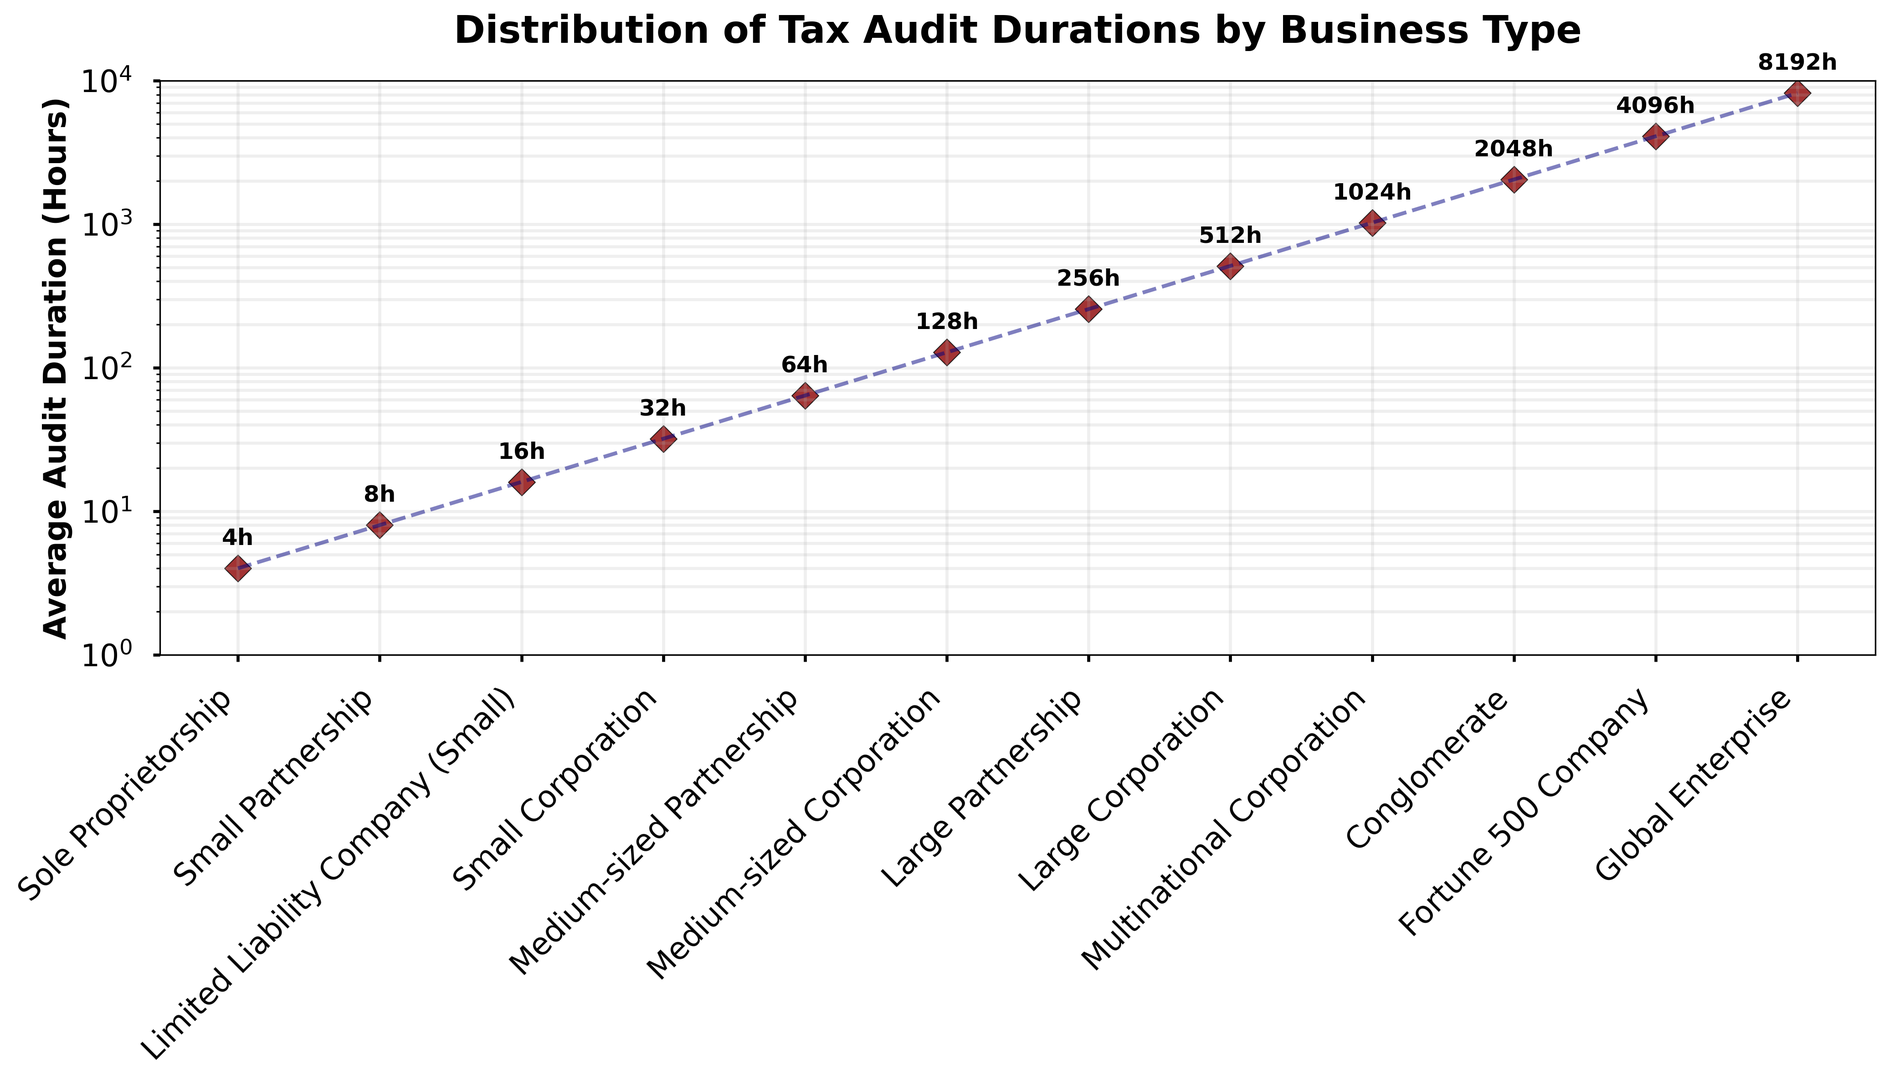What's the business type with the shortest average audit duration? By looking at the leftmost point on the x-axis (representing business types) and the lowest position on the y-axis (representing audit duration in hours), we see that "Sole Proprietorship" is located there. Its average audit duration is 4 hours.
Answer: Sole Proprietorship Which business type has the longest average audit duration? By examining the rightmost point on the x-axis and the highest position on the y-axis, we identify "Global Enterprise" as having the longest duration, which is 8192 hours.
Answer: Global Enterprise What is the average audit duration for "Large Corporation" and "Multinational Corporation"? Find the y-values for both "Large Corporation" and "Multinational Corporation" from the plot. They are 512 hours and 1024 hours, respectively. The average is calculated as (512 + 1024) / 2 = 768 hours.
Answer: 768 How much longer is the audit duration for a "Conglomerate" compared to a "Medium-sized Corporation"? The audit duration for a "Conglomerate" is 2048 hours and for a "Medium-sized Corporation" is 128 hours. The difference is 2048 - 128 = 1920 hours.
Answer: 1920 Rank the following business types by audit duration: "Small Corporation," "Medium-sized Partnership," and "Limited Liability Company (Small)". Locate each business on the x-axis and note their y-values. "Limited Liability Company (Small)" has 16 hours, "Small Corporation" has 32 hours, and "Medium-sized Partnership" has 64 hours. Ranking from shortest to longest gives: "Limited Liability Company (Small)", "Small Corporation", "Medium-sized Partnership".
Answer: Limited Liability Company (Small), Small Corporation, Medium-sized Partnership What is the logarithmic range of the audit durations shown in the plot? The plot shows a y-axis scaled logarithmically from 1 to 10000. Therefore, the range in a logarithmic sense spans from 1 to 8192 hours.
Answer: 1 to 8192 If the audit duration for "Fortune 500 Company" is doubled, how would it compare to the current duration for "Global Enterprise"? The current duration for "Fortune 500 Company" is 4096 hours. Doubling it gives 4096 * 2 = 8192 hours, which exactly matches the current duration of "Global Enterprise". Therefore, it will be equal.
Answer: Equal Identify the business type with an average audit duration of 64 hours and name one with half that duration. The plot shows that "Medium-sized Partnership" has an audit duration of 64 hours. Half of 64 hours is 32 hours, seen for "Small Corporation".
Answer: Medium-sized Partnership and Small Corporation What step visually indicates that the duration increases exponentially rather than linearly as businesses grow in size? The line in the plot connects the points and shows a steep, exponential-like increase. A logscale y-axis is used to handle large differences in duration, indicating exponential growth.
Answer: Logscale y-axis and steep line trend Which is closer to the average audit duration, "Medium-sized Corporation" or "Fortune 500 Company"? Calculate the average audit duration across all business types. Total audit hours are the sum of all y-values, and the average is this sum divided by the number of types. Comparing the figures for "Medium-sized Corporation" (128 hours) and "Fortune 500 Company" (4096 hours), see which is closer to the calculated average.
Answer: Medium-sized Corporation 